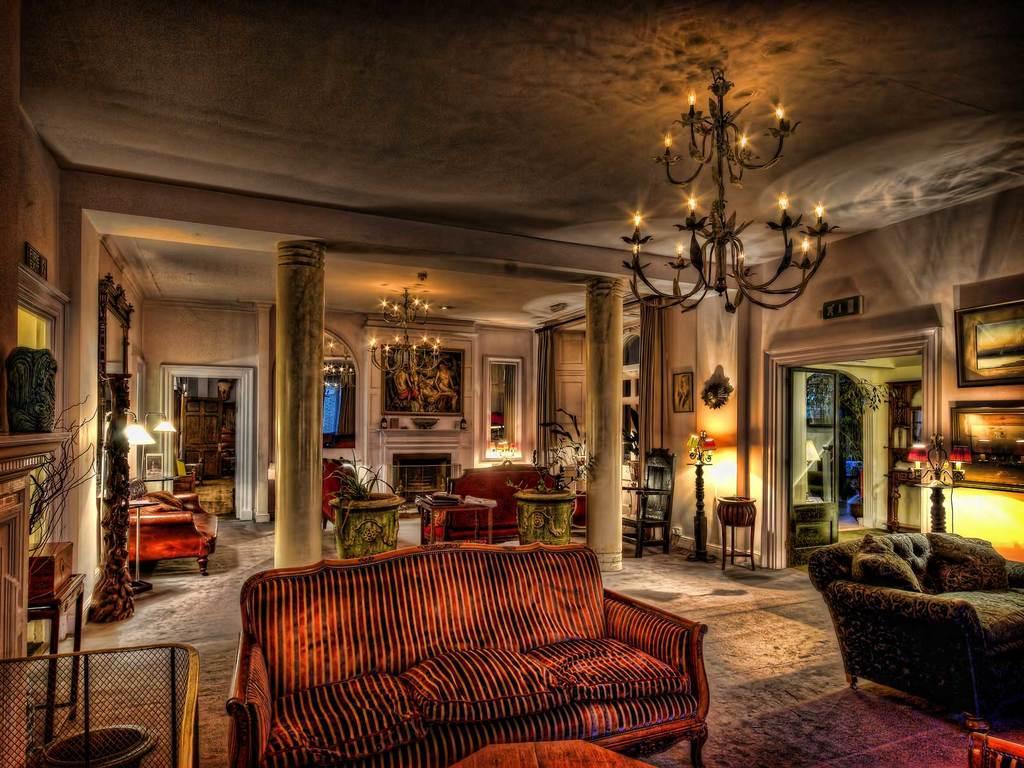Can you describe this image briefly? It is a living room there are sofa sets, lamps and photo frames in the room and on the right side there is another room and there are two pillars in between the room. 